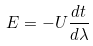<formula> <loc_0><loc_0><loc_500><loc_500>E = - U \frac { d t } { d \lambda }</formula> 